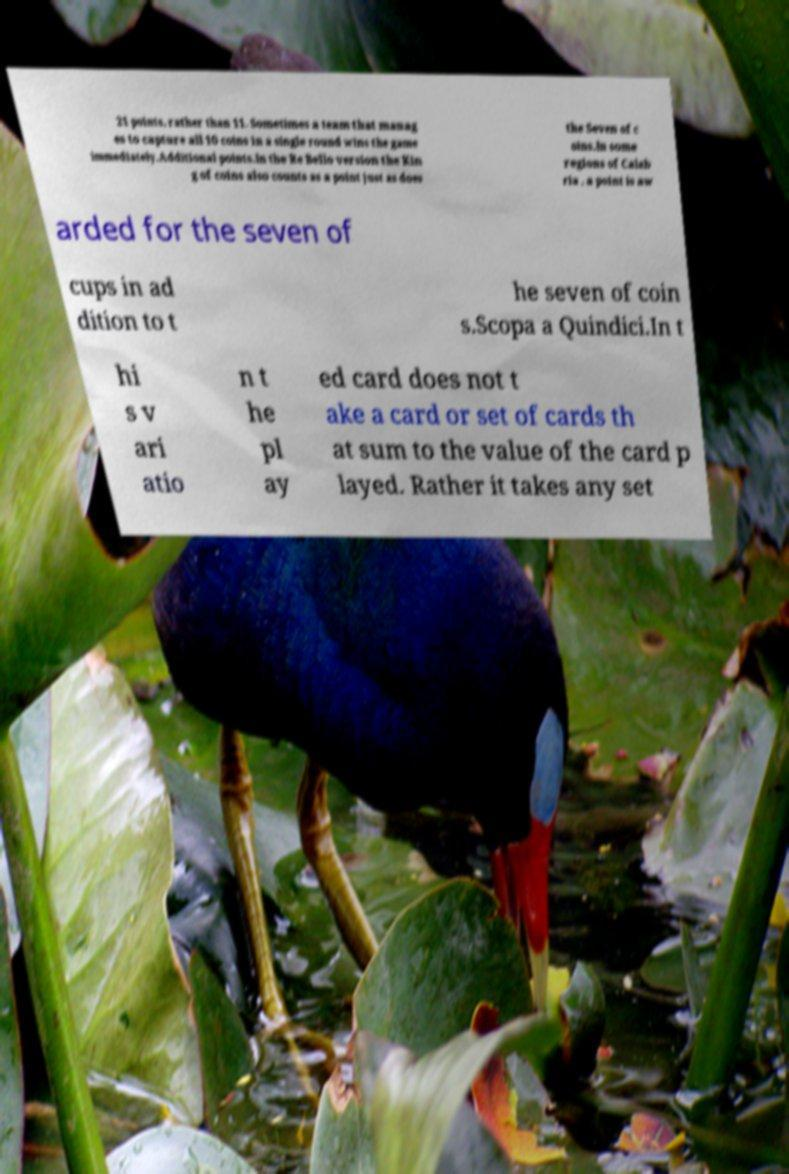Could you assist in decoding the text presented in this image and type it out clearly? 21 points, rather than 11. Sometimes a team that manag es to capture all 10 coins in a single round wins the game immediately.Additional points.In the Re Bello version the Kin g of coins also counts as a point just as does the Seven of c oins.In some regions of Calab ria , a point is aw arded for the seven of cups in ad dition to t he seven of coin s.Scopa a Quindici.In t hi s v ari atio n t he pl ay ed card does not t ake a card or set of cards th at sum to the value of the card p layed. Rather it takes any set 